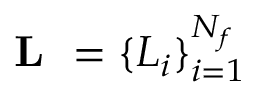<formula> <loc_0><loc_0><loc_500><loc_500>L = \{ L _ { i } \} _ { i = 1 } ^ { N _ { f } }</formula> 